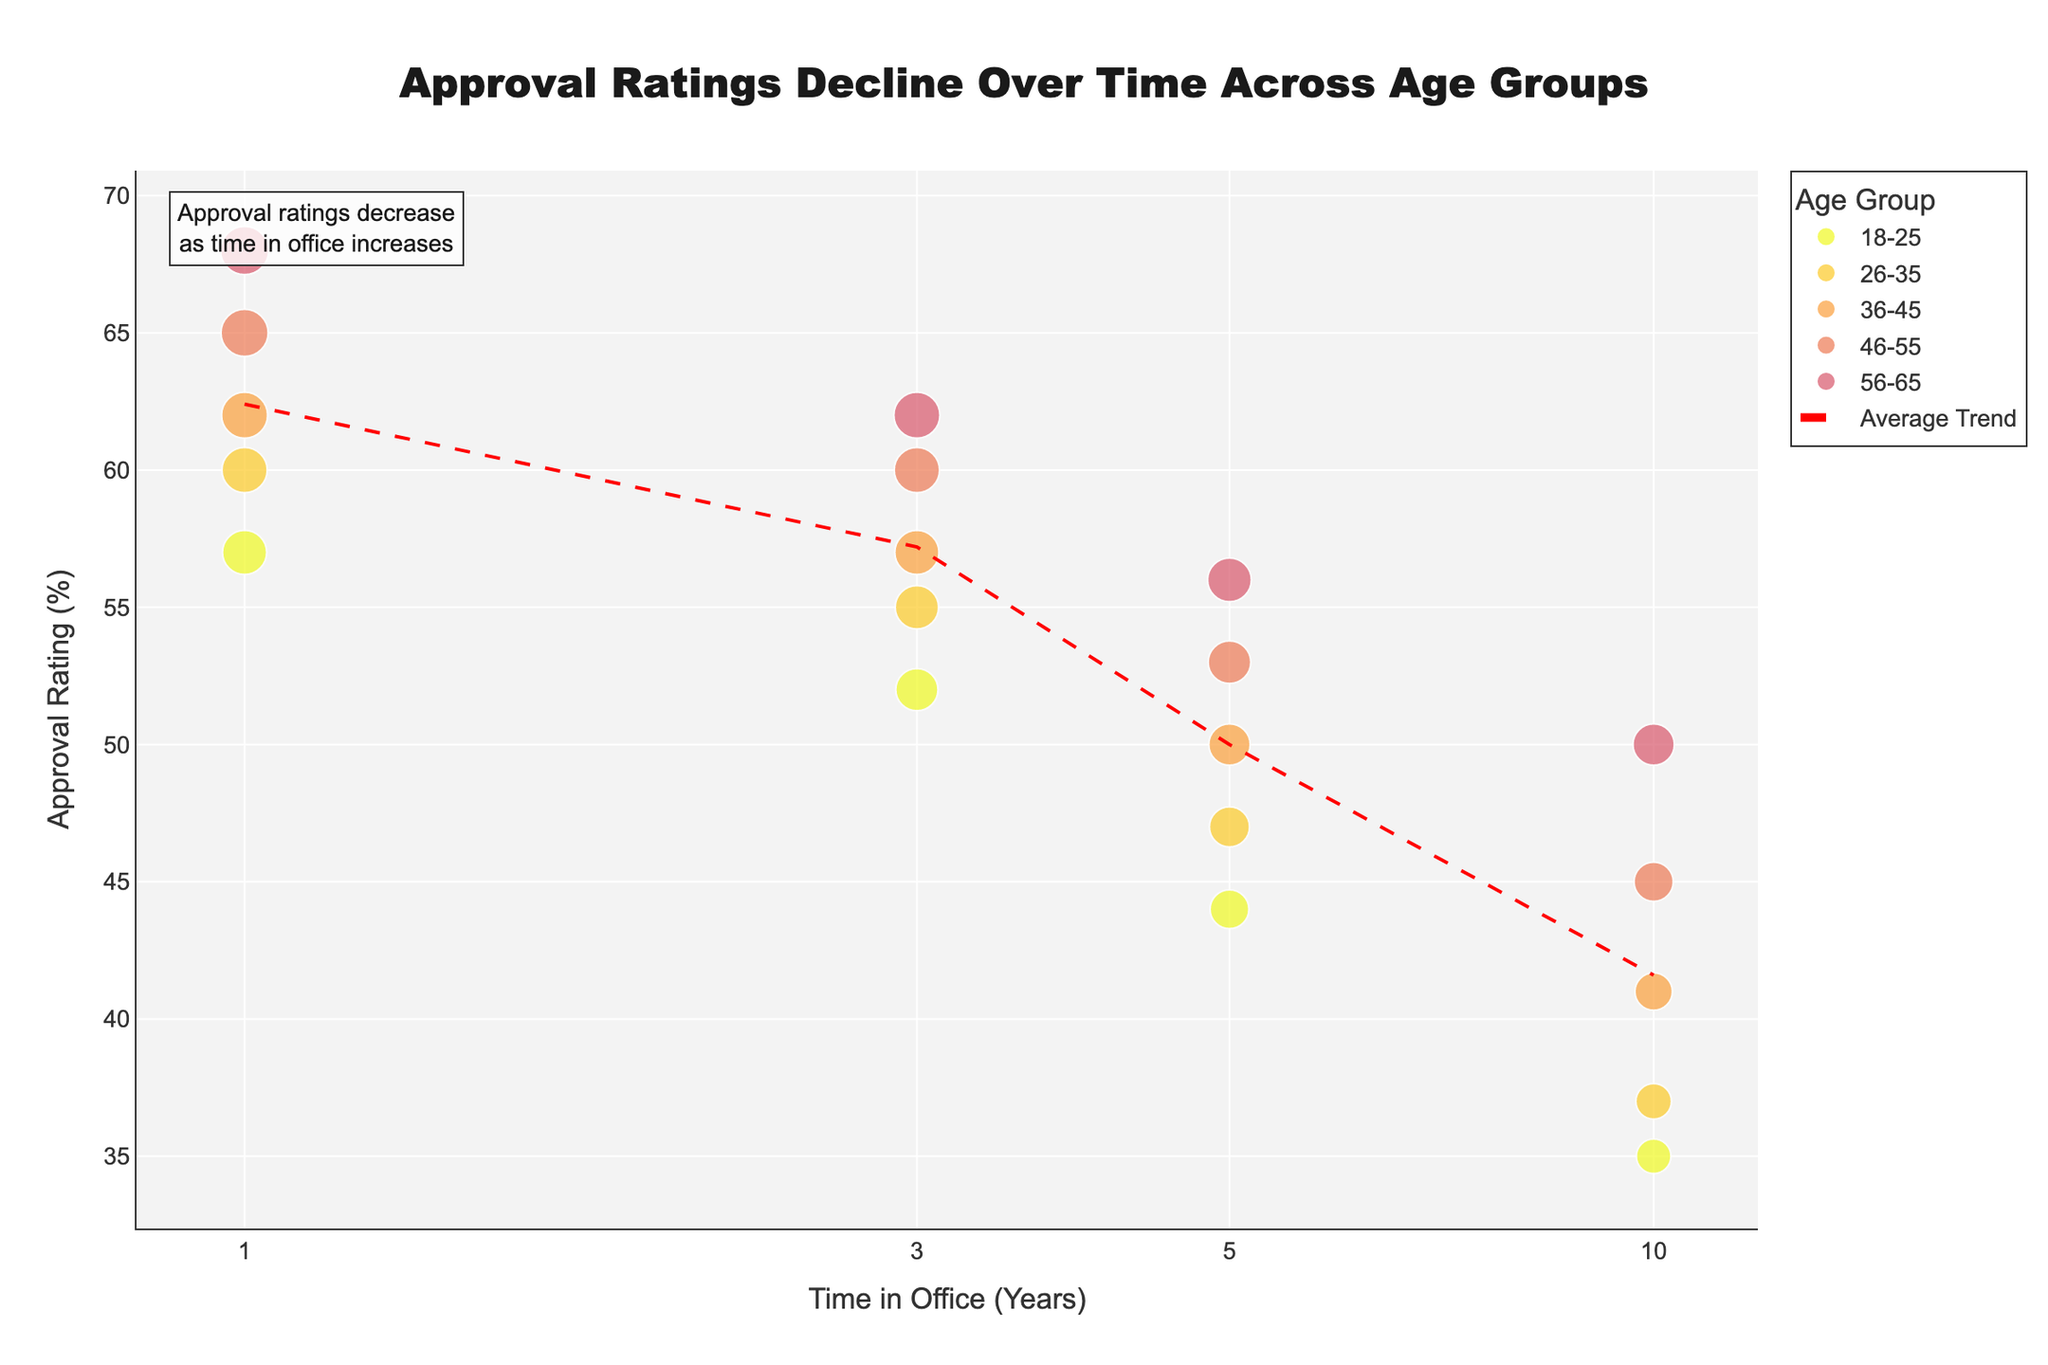What is the title of the figure? The title of the figure is typically found at the top and is meant to describe the overall theme or takeaway message from the data presented. In this case, it's centrally aligned and easy to read.
Answer: Approval Ratings Decline Over Time Across Age Groups How does the trend change for approval ratings as time in office increases? The trend can be observed by looking at the red dashed line representing the average trend over the different time periods. It generally shows a decrease in approval ratings as time in office increases.
Answer: Approval ratings decrease Which age group has the highest initial approval rating at 1 year in office? By examining the color-coded scatter points for the different age groups at the 1-year mark on the x-axis, the 56-65 age group can be seen to have the highest approval rating.
Answer: 56-65 What is the approval rating for the 18-25 age group after 10 years in office? Locate the data points for the 18-25 age group along the scatter plot, specifically at the 10-year mark on the x-axis. The corresponding approval rating is shown.
Answer: 35% Compare the approval ratings for the 26-35 age group between 3 and 5 years in office. Which is higher? Look at the data points for the 26-35 age group at the 3-year and 5-year marks on the x-axis. Compare their positions on the y-axis to determine which is higher.
Answer: 3 years Between which years does the 46-55 age group experience the largest drop in approval ratings? Observe the scatter plot points for the 46-55 age group and compare the change in their y-axis positions between consecutive years. Identify the interval with the steepest decline.
Answer: Between year 5 and 10 What's the average approval rating for all age groups at 5 years in office? To find the average, locate all data points on the scatter plot that correspond to 5 years in office, sum their y-axis values, and divide by the number of data points.
Answer: 50 Which age group maintains the most stable approval rating across different time periods? Evaluate the scatter points for each age group and assess which group shows the least variance or fluctuation in their positions on the y-axis.
Answer: 56-65 What can be inferred about younger versus older age groups' approval ratings over time? Compare the scatter plot trends for younger (18-25, 26-35) and older age groups (46-55, 56-65). Notice that younger age groups seem to start with lower ratings and decrease more rapidly, whereas older age groups start higher and are more stable.
Answer: Older age groups start higher and are more stable How does the scatter size relate to the data in the figure? The size of each scatter point varies, as indicated in the legend, representing the approval ratings. Larger scatter points indicate higher approval percentages, adding a dimension of data visualization.
Answer: Size corresponds to approval ratings (%) 